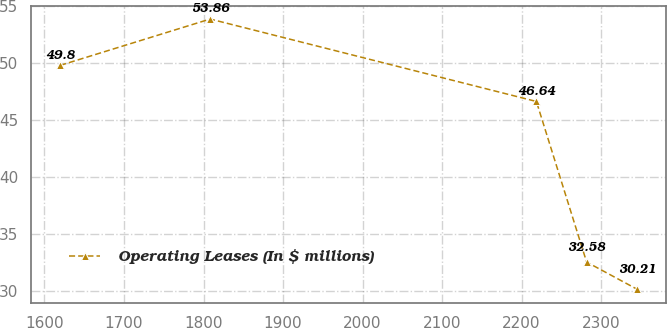Convert chart to OTSL. <chart><loc_0><loc_0><loc_500><loc_500><line_chart><ecel><fcel>Operating Leases (In $ millions)<nl><fcel>1619.67<fcel>49.8<nl><fcel>1808.36<fcel>53.86<nl><fcel>2218.64<fcel>46.64<nl><fcel>2281.78<fcel>32.58<nl><fcel>2344.92<fcel>30.21<nl></chart> 